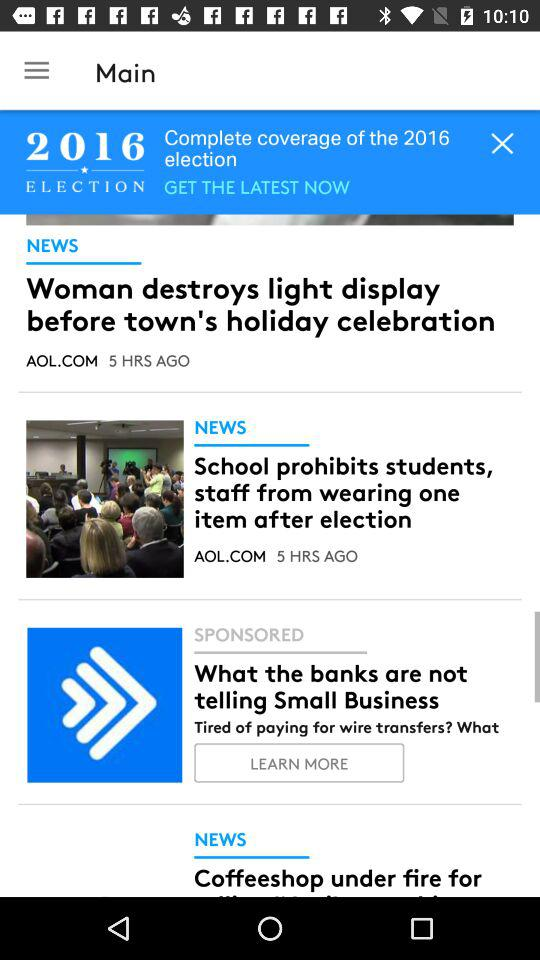How many more news articles are there than sponsored articles?
Answer the question using a single word or phrase. 2 